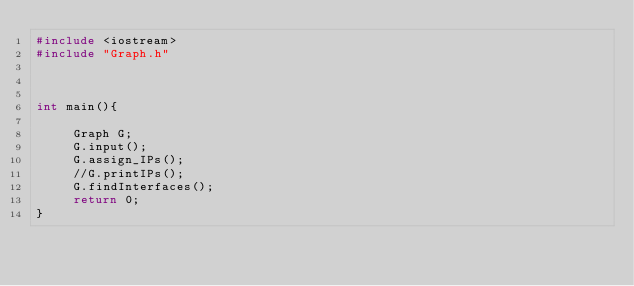Convert code to text. <code><loc_0><loc_0><loc_500><loc_500><_C++_>#include <iostream>
#include "Graph.h"



int main(){

     Graph G;
     G.input();
     G.assign_IPs();
     //G.printIPs();
     G.findInterfaces();
     return 0;
}
</code> 